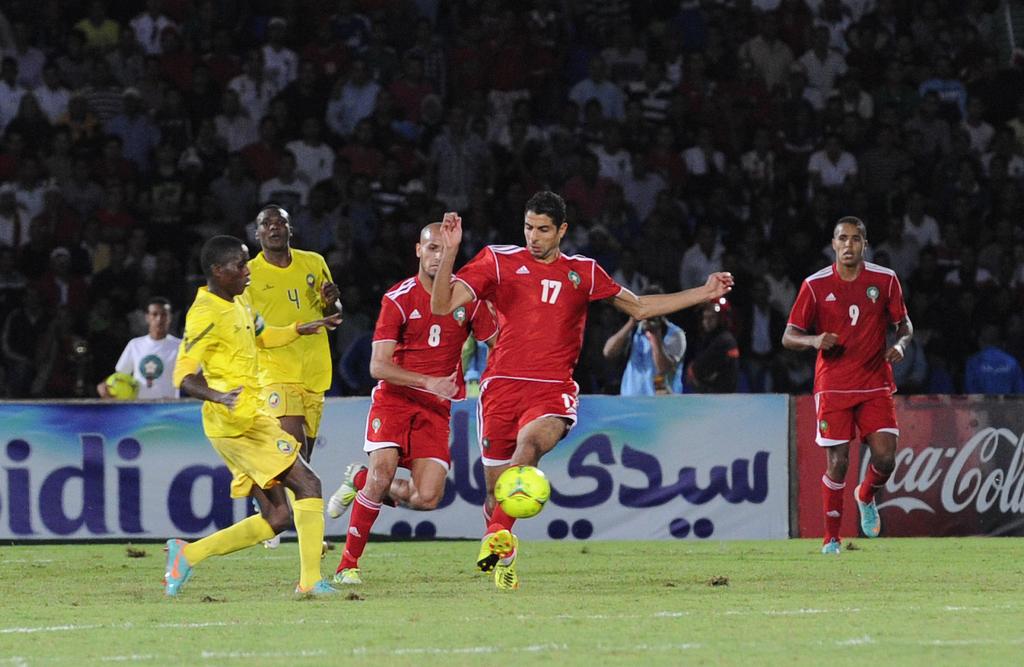What number is the player kicking the ball?
Your answer should be compact. 17. 